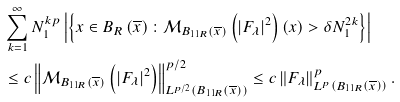<formula> <loc_0><loc_0><loc_500><loc_500>& \sum _ { k = 1 } ^ { \infty } N _ { 1 } ^ { k p } \left | \left \{ x \in B _ { R } \left ( \overline { x } \right ) \colon \mathcal { M } _ { B _ { 1 1 R } \left ( \overline { x } \right ) } \left ( \left | F _ { \lambda } \right | ^ { 2 } \right ) \left ( x \right ) > \delta N _ { 1 } ^ { 2 k } \right \} \right | \\ & \leq c \left \| \mathcal { M } _ { B _ { 1 1 R } \left ( \overline { x } \right ) } \left ( \left | F _ { \lambda } \right | ^ { 2 } \right ) \right \| _ { L ^ { p / 2 } \left ( B _ { 1 1 R } \left ( \overline { x } \right ) \right ) } ^ { p / 2 } \leq c \left \| F _ { \lambda } \right \| _ { L ^ { p } \left ( B _ { 1 1 R } \left ( \overline { x } \right ) \right ) } ^ { p } .</formula> 